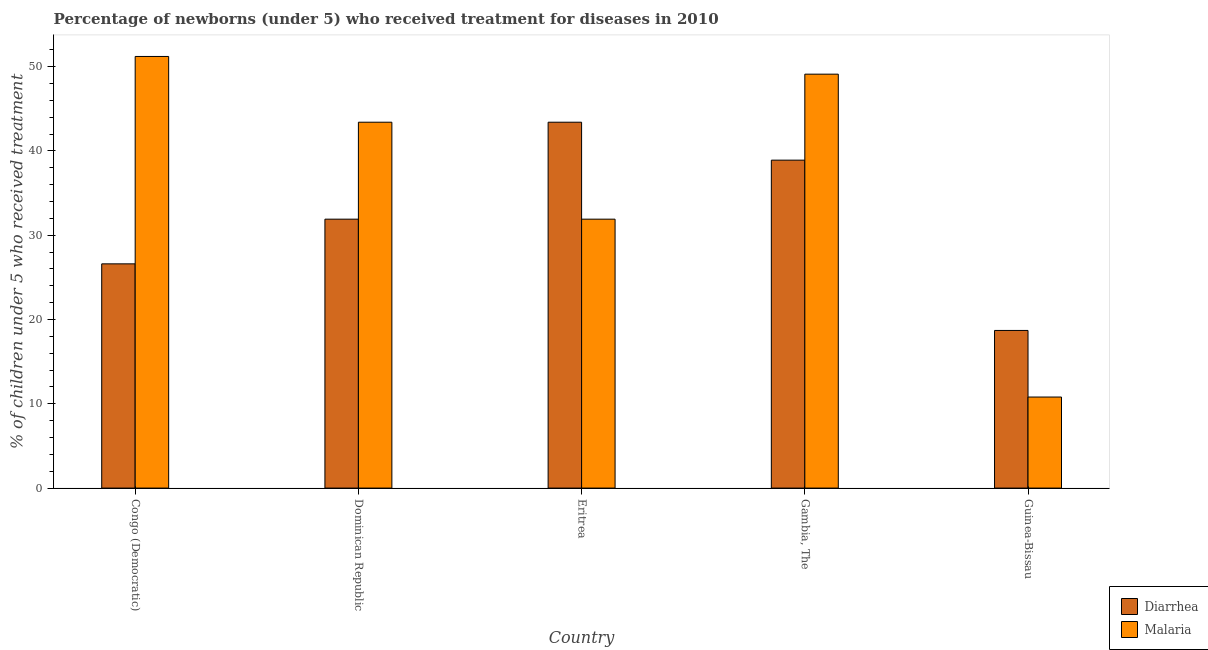How many groups of bars are there?
Your answer should be compact. 5. What is the label of the 2nd group of bars from the left?
Ensure brevity in your answer.  Dominican Republic. What is the percentage of children who received treatment for malaria in Dominican Republic?
Provide a succinct answer. 43.4. Across all countries, what is the maximum percentage of children who received treatment for malaria?
Provide a short and direct response. 51.2. Across all countries, what is the minimum percentage of children who received treatment for malaria?
Keep it short and to the point. 10.8. In which country was the percentage of children who received treatment for diarrhoea maximum?
Your answer should be very brief. Eritrea. In which country was the percentage of children who received treatment for malaria minimum?
Your answer should be very brief. Guinea-Bissau. What is the total percentage of children who received treatment for malaria in the graph?
Offer a terse response. 186.4. What is the difference between the percentage of children who received treatment for malaria in Congo (Democratic) and the percentage of children who received treatment for diarrhoea in Eritrea?
Your answer should be compact. 7.8. What is the average percentage of children who received treatment for diarrhoea per country?
Provide a succinct answer. 31.9. What is the difference between the percentage of children who received treatment for diarrhoea and percentage of children who received treatment for malaria in Eritrea?
Your response must be concise. 11.5. What is the ratio of the percentage of children who received treatment for diarrhoea in Congo (Democratic) to that in Eritrea?
Ensure brevity in your answer.  0.61. Is the percentage of children who received treatment for diarrhoea in Eritrea less than that in Gambia, The?
Ensure brevity in your answer.  No. What is the difference between the highest and the second highest percentage of children who received treatment for diarrhoea?
Your answer should be compact. 4.5. What is the difference between the highest and the lowest percentage of children who received treatment for malaria?
Your answer should be compact. 40.4. What does the 2nd bar from the left in Congo (Democratic) represents?
Give a very brief answer. Malaria. What does the 1st bar from the right in Congo (Democratic) represents?
Keep it short and to the point. Malaria. How many countries are there in the graph?
Ensure brevity in your answer.  5. What is the difference between two consecutive major ticks on the Y-axis?
Provide a succinct answer. 10. Are the values on the major ticks of Y-axis written in scientific E-notation?
Give a very brief answer. No. Does the graph contain any zero values?
Provide a short and direct response. No. Does the graph contain grids?
Make the answer very short. No. How many legend labels are there?
Ensure brevity in your answer.  2. What is the title of the graph?
Make the answer very short. Percentage of newborns (under 5) who received treatment for diseases in 2010. What is the label or title of the Y-axis?
Make the answer very short. % of children under 5 who received treatment. What is the % of children under 5 who received treatment in Diarrhea in Congo (Democratic)?
Offer a terse response. 26.6. What is the % of children under 5 who received treatment in Malaria in Congo (Democratic)?
Your answer should be very brief. 51.2. What is the % of children under 5 who received treatment of Diarrhea in Dominican Republic?
Make the answer very short. 31.9. What is the % of children under 5 who received treatment of Malaria in Dominican Republic?
Keep it short and to the point. 43.4. What is the % of children under 5 who received treatment of Diarrhea in Eritrea?
Your response must be concise. 43.4. What is the % of children under 5 who received treatment of Malaria in Eritrea?
Ensure brevity in your answer.  31.9. What is the % of children under 5 who received treatment of Diarrhea in Gambia, The?
Ensure brevity in your answer.  38.9. What is the % of children under 5 who received treatment in Malaria in Gambia, The?
Give a very brief answer. 49.1. What is the % of children under 5 who received treatment in Malaria in Guinea-Bissau?
Provide a succinct answer. 10.8. Across all countries, what is the maximum % of children under 5 who received treatment of Diarrhea?
Your answer should be very brief. 43.4. Across all countries, what is the maximum % of children under 5 who received treatment of Malaria?
Keep it short and to the point. 51.2. Across all countries, what is the minimum % of children under 5 who received treatment in Diarrhea?
Offer a very short reply. 18.7. What is the total % of children under 5 who received treatment of Diarrhea in the graph?
Your response must be concise. 159.5. What is the total % of children under 5 who received treatment of Malaria in the graph?
Your response must be concise. 186.4. What is the difference between the % of children under 5 who received treatment of Malaria in Congo (Democratic) and that in Dominican Republic?
Ensure brevity in your answer.  7.8. What is the difference between the % of children under 5 who received treatment in Diarrhea in Congo (Democratic) and that in Eritrea?
Your response must be concise. -16.8. What is the difference between the % of children under 5 who received treatment of Malaria in Congo (Democratic) and that in Eritrea?
Offer a terse response. 19.3. What is the difference between the % of children under 5 who received treatment in Diarrhea in Congo (Democratic) and that in Guinea-Bissau?
Ensure brevity in your answer.  7.9. What is the difference between the % of children under 5 who received treatment in Malaria in Congo (Democratic) and that in Guinea-Bissau?
Your answer should be compact. 40.4. What is the difference between the % of children under 5 who received treatment of Malaria in Dominican Republic and that in Eritrea?
Provide a succinct answer. 11.5. What is the difference between the % of children under 5 who received treatment in Diarrhea in Dominican Republic and that in Gambia, The?
Offer a very short reply. -7. What is the difference between the % of children under 5 who received treatment of Malaria in Dominican Republic and that in Gambia, The?
Make the answer very short. -5.7. What is the difference between the % of children under 5 who received treatment of Malaria in Dominican Republic and that in Guinea-Bissau?
Your answer should be very brief. 32.6. What is the difference between the % of children under 5 who received treatment of Malaria in Eritrea and that in Gambia, The?
Give a very brief answer. -17.2. What is the difference between the % of children under 5 who received treatment in Diarrhea in Eritrea and that in Guinea-Bissau?
Offer a terse response. 24.7. What is the difference between the % of children under 5 who received treatment of Malaria in Eritrea and that in Guinea-Bissau?
Your response must be concise. 21.1. What is the difference between the % of children under 5 who received treatment of Diarrhea in Gambia, The and that in Guinea-Bissau?
Offer a terse response. 20.2. What is the difference between the % of children under 5 who received treatment in Malaria in Gambia, The and that in Guinea-Bissau?
Your answer should be very brief. 38.3. What is the difference between the % of children under 5 who received treatment in Diarrhea in Congo (Democratic) and the % of children under 5 who received treatment in Malaria in Dominican Republic?
Give a very brief answer. -16.8. What is the difference between the % of children under 5 who received treatment in Diarrhea in Congo (Democratic) and the % of children under 5 who received treatment in Malaria in Gambia, The?
Make the answer very short. -22.5. What is the difference between the % of children under 5 who received treatment of Diarrhea in Congo (Democratic) and the % of children under 5 who received treatment of Malaria in Guinea-Bissau?
Offer a very short reply. 15.8. What is the difference between the % of children under 5 who received treatment of Diarrhea in Dominican Republic and the % of children under 5 who received treatment of Malaria in Eritrea?
Keep it short and to the point. 0. What is the difference between the % of children under 5 who received treatment of Diarrhea in Dominican Republic and the % of children under 5 who received treatment of Malaria in Gambia, The?
Offer a terse response. -17.2. What is the difference between the % of children under 5 who received treatment in Diarrhea in Dominican Republic and the % of children under 5 who received treatment in Malaria in Guinea-Bissau?
Offer a very short reply. 21.1. What is the difference between the % of children under 5 who received treatment of Diarrhea in Eritrea and the % of children under 5 who received treatment of Malaria in Guinea-Bissau?
Your answer should be very brief. 32.6. What is the difference between the % of children under 5 who received treatment in Diarrhea in Gambia, The and the % of children under 5 who received treatment in Malaria in Guinea-Bissau?
Make the answer very short. 28.1. What is the average % of children under 5 who received treatment of Diarrhea per country?
Your answer should be very brief. 31.9. What is the average % of children under 5 who received treatment in Malaria per country?
Provide a succinct answer. 37.28. What is the difference between the % of children under 5 who received treatment of Diarrhea and % of children under 5 who received treatment of Malaria in Congo (Democratic)?
Provide a short and direct response. -24.6. What is the difference between the % of children under 5 who received treatment in Diarrhea and % of children under 5 who received treatment in Malaria in Gambia, The?
Your answer should be compact. -10.2. What is the difference between the % of children under 5 who received treatment in Diarrhea and % of children under 5 who received treatment in Malaria in Guinea-Bissau?
Offer a very short reply. 7.9. What is the ratio of the % of children under 5 who received treatment of Diarrhea in Congo (Democratic) to that in Dominican Republic?
Offer a terse response. 0.83. What is the ratio of the % of children under 5 who received treatment of Malaria in Congo (Democratic) to that in Dominican Republic?
Ensure brevity in your answer.  1.18. What is the ratio of the % of children under 5 who received treatment of Diarrhea in Congo (Democratic) to that in Eritrea?
Make the answer very short. 0.61. What is the ratio of the % of children under 5 who received treatment in Malaria in Congo (Democratic) to that in Eritrea?
Your answer should be compact. 1.6. What is the ratio of the % of children under 5 who received treatment of Diarrhea in Congo (Democratic) to that in Gambia, The?
Make the answer very short. 0.68. What is the ratio of the % of children under 5 who received treatment in Malaria in Congo (Democratic) to that in Gambia, The?
Ensure brevity in your answer.  1.04. What is the ratio of the % of children under 5 who received treatment in Diarrhea in Congo (Democratic) to that in Guinea-Bissau?
Your answer should be very brief. 1.42. What is the ratio of the % of children under 5 who received treatment of Malaria in Congo (Democratic) to that in Guinea-Bissau?
Offer a terse response. 4.74. What is the ratio of the % of children under 5 who received treatment of Diarrhea in Dominican Republic to that in Eritrea?
Provide a succinct answer. 0.73. What is the ratio of the % of children under 5 who received treatment in Malaria in Dominican Republic to that in Eritrea?
Provide a short and direct response. 1.36. What is the ratio of the % of children under 5 who received treatment in Diarrhea in Dominican Republic to that in Gambia, The?
Offer a very short reply. 0.82. What is the ratio of the % of children under 5 who received treatment in Malaria in Dominican Republic to that in Gambia, The?
Ensure brevity in your answer.  0.88. What is the ratio of the % of children under 5 who received treatment in Diarrhea in Dominican Republic to that in Guinea-Bissau?
Keep it short and to the point. 1.71. What is the ratio of the % of children under 5 who received treatment in Malaria in Dominican Republic to that in Guinea-Bissau?
Provide a short and direct response. 4.02. What is the ratio of the % of children under 5 who received treatment of Diarrhea in Eritrea to that in Gambia, The?
Give a very brief answer. 1.12. What is the ratio of the % of children under 5 who received treatment of Malaria in Eritrea to that in Gambia, The?
Provide a short and direct response. 0.65. What is the ratio of the % of children under 5 who received treatment in Diarrhea in Eritrea to that in Guinea-Bissau?
Your response must be concise. 2.32. What is the ratio of the % of children under 5 who received treatment of Malaria in Eritrea to that in Guinea-Bissau?
Give a very brief answer. 2.95. What is the ratio of the % of children under 5 who received treatment of Diarrhea in Gambia, The to that in Guinea-Bissau?
Your answer should be very brief. 2.08. What is the ratio of the % of children under 5 who received treatment in Malaria in Gambia, The to that in Guinea-Bissau?
Keep it short and to the point. 4.55. What is the difference between the highest and the lowest % of children under 5 who received treatment of Diarrhea?
Ensure brevity in your answer.  24.7. What is the difference between the highest and the lowest % of children under 5 who received treatment in Malaria?
Keep it short and to the point. 40.4. 